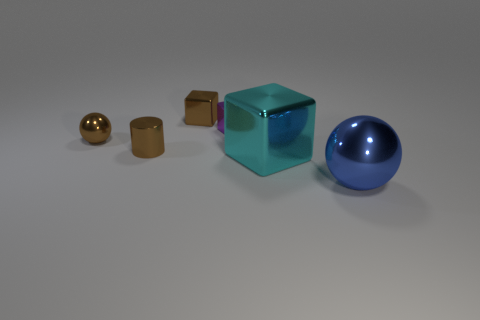Subtract all small purple metal blocks. How many blocks are left? 2 Subtract 1 blocks. How many blocks are left? 2 Add 4 big yellow rubber cubes. How many objects exist? 10 Subtract all spheres. How many objects are left? 4 Add 2 large things. How many large things are left? 4 Add 6 large yellow rubber cylinders. How many large yellow rubber cylinders exist? 6 Subtract 0 cyan cylinders. How many objects are left? 6 Subtract all small brown metal spheres. Subtract all big green matte cubes. How many objects are left? 5 